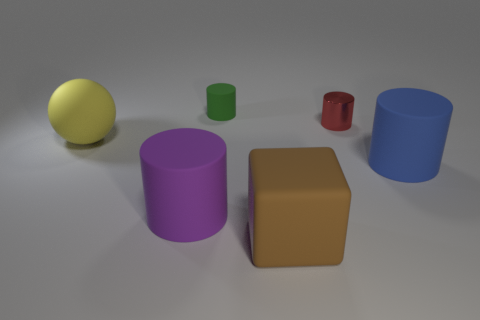Subtract all green rubber cylinders. How many cylinders are left? 3 Subtract all cylinders. How many objects are left? 2 Subtract all purple cylinders. How many cylinders are left? 3 Subtract 0 red balls. How many objects are left? 6 Subtract 3 cylinders. How many cylinders are left? 1 Subtract all green cubes. Subtract all purple balls. How many cubes are left? 1 Subtract all yellow cubes. How many red spheres are left? 0 Subtract all tiny gray blocks. Subtract all big matte balls. How many objects are left? 5 Add 1 big brown matte things. How many big brown matte things are left? 2 Add 1 small gray things. How many small gray things exist? 1 